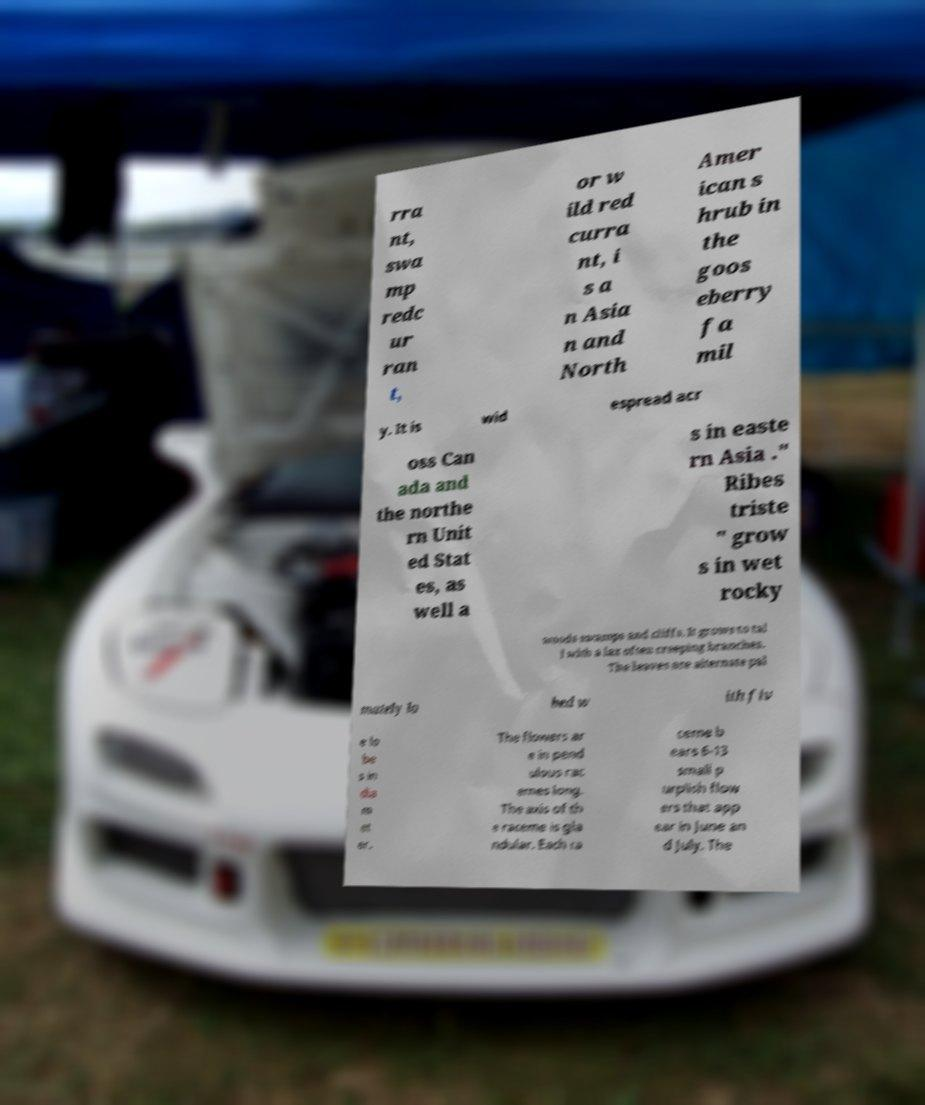Could you assist in decoding the text presented in this image and type it out clearly? rra nt, swa mp redc ur ran t, or w ild red curra nt, i s a n Asia n and North Amer ican s hrub in the goos eberry fa mil y. It is wid espread acr oss Can ada and the northe rn Unit ed Stat es, as well a s in easte rn Asia ." Ribes triste " grow s in wet rocky woods swamps and cliffs. It grows to tal l with a lax often creeping branches. The leaves are alternate pal mately lo bed w ith fiv e lo be s in dia m et er. The flowers ar e in pend ulous rac emes long. The axis of th e raceme is gla ndular. Each ra ceme b ears 6-13 small p urplish flow ers that app ear in June an d July. The 